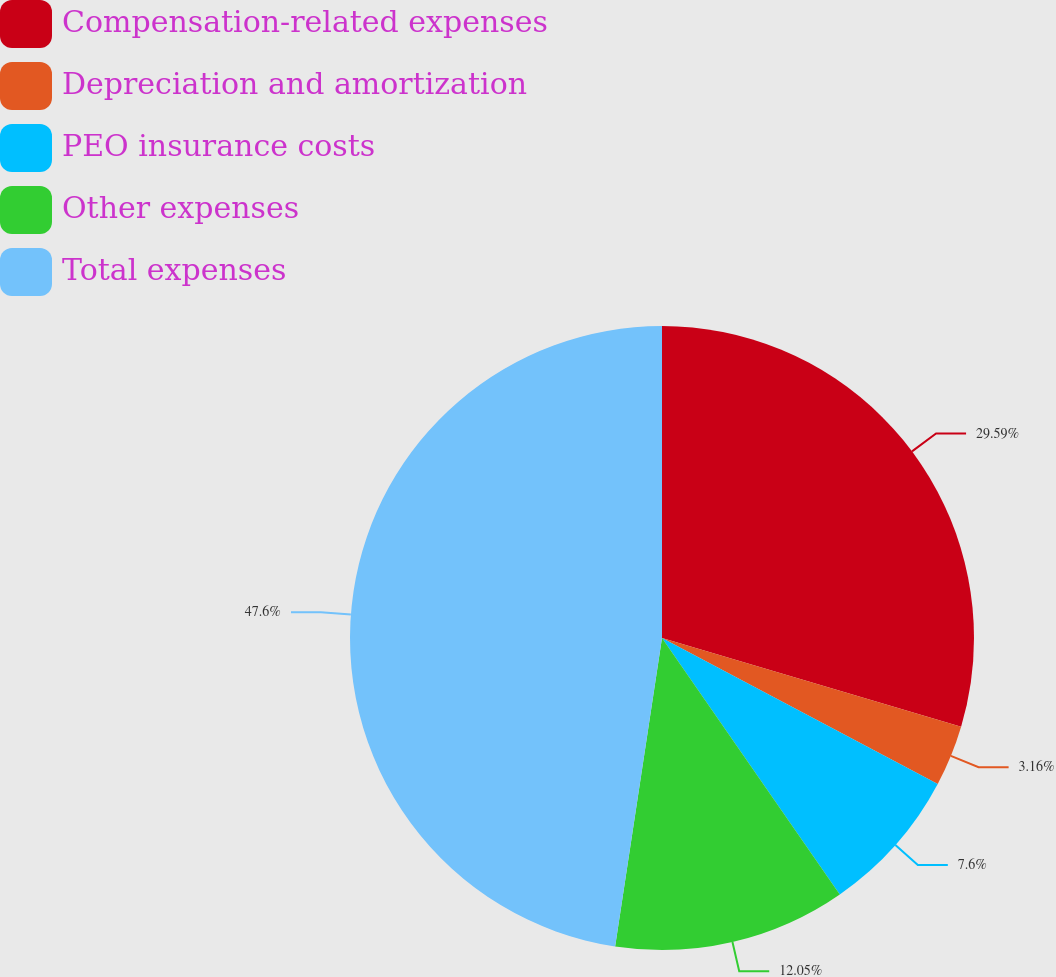<chart> <loc_0><loc_0><loc_500><loc_500><pie_chart><fcel>Compensation-related expenses<fcel>Depreciation and amortization<fcel>PEO insurance costs<fcel>Other expenses<fcel>Total expenses<nl><fcel>29.59%<fcel>3.16%<fcel>7.6%<fcel>12.05%<fcel>47.6%<nl></chart> 